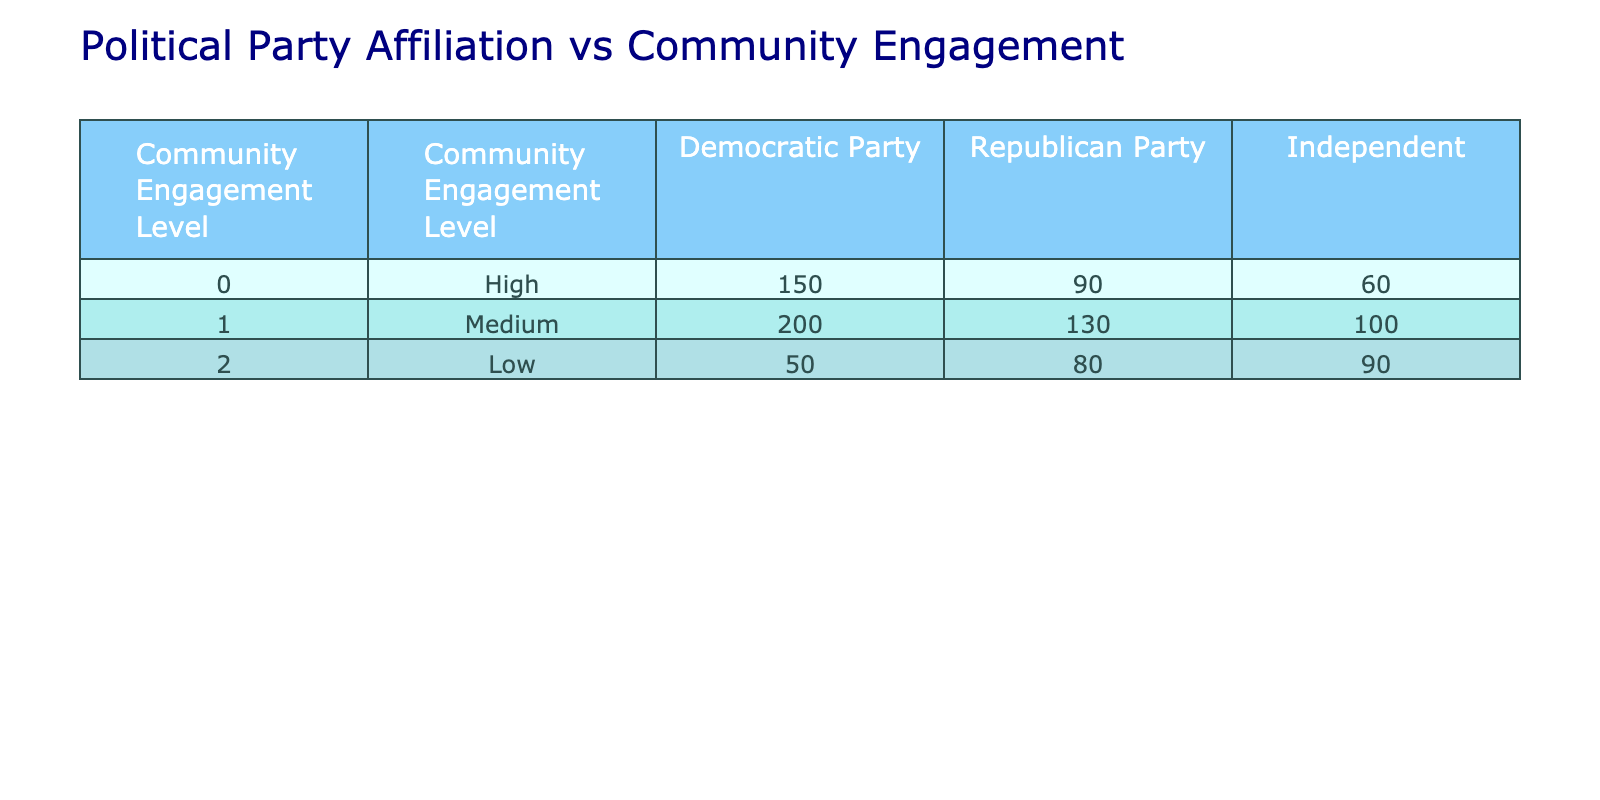What is the total number of individuals engaged at a high level within the Democratic Party? From the table, the Democratic Party has 150 individuals classified under the high community engagement level.
Answer: 150 How many individuals affiliated with the Republican Party have low community engagement? The table shows that the Republican Party has 80 individuals categorized under low community engagement.
Answer: 80 What is the sum of individuals engaged at a medium level for all political affiliations? The medium level numbers are 200 for Democrats, 130 for Republicans, and 100 for Independents. Adding them gives 200 + 130 + 100 = 430.
Answer: 430 Is there a higher number of Independents with a high level of engagement than Republicans? The table shows 60 Independents engaged at a high level and 90 Republicans. Since 60 is less than 90, the statement is false.
Answer: No What is the average number of individuals in the Democratic Party across all levels of community engagement? The Democratic Party has 150 high, 200 medium, and 50 low engagement individuals. The sum is 150 + 200 + 50 = 400, divided by 3 levels gives an average of 400/3 ≈ 133.33.
Answer: Approximately 133.33 Which party has the highest total number of individuals across all engagement levels? Summing for each party: Democratic Party has 150 + 200 + 50 = 400; Republican Party has 90 + 130 + 80 = 300; Independent has 60 + 100 + 90 = 250. The Democratic Party has the highest total of 400.
Answer: Democratic Party What is the difference in the number of individuals engaged at a medium level between the Democratic Party and the Republican Party? The Democratic Party has 200 at a medium level while the Republican Party has 130. The difference is 200 - 130 = 70.
Answer: 70 Which political party has the lowest overall community engagement total? Calculating totals: Democrats = 400, Republicans = 300, Independents = 250. Independents have the lowest total of 250.
Answer: Independents 